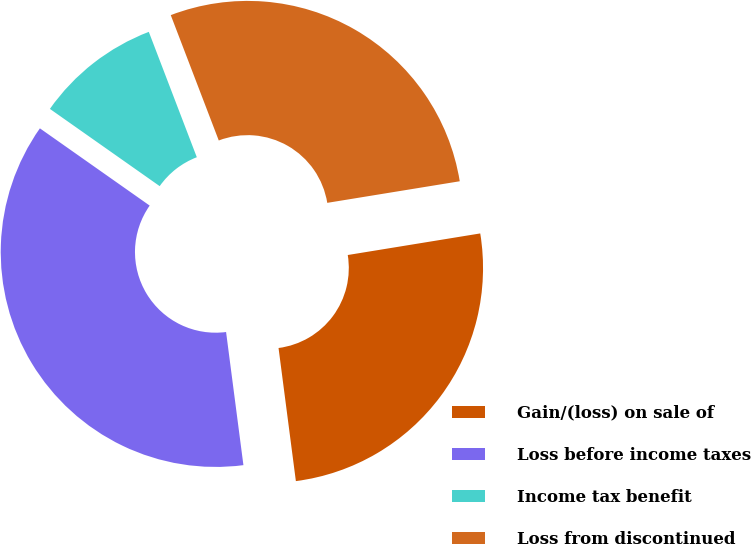Convert chart. <chart><loc_0><loc_0><loc_500><loc_500><pie_chart><fcel>Gain/(loss) on sale of<fcel>Loss before income taxes<fcel>Income tax benefit<fcel>Loss from discontinued<nl><fcel>25.51%<fcel>36.82%<fcel>9.42%<fcel>28.25%<nl></chart> 